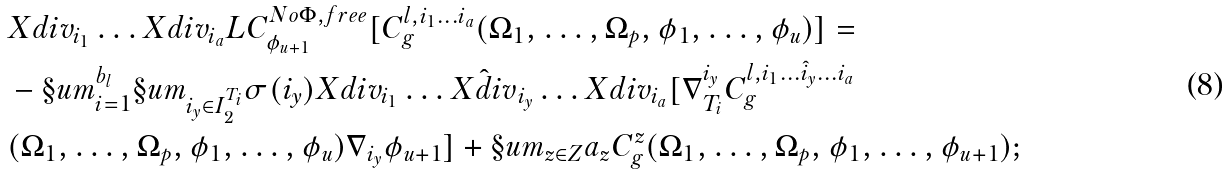Convert formula to latex. <formula><loc_0><loc_0><loc_500><loc_500>& X d i v _ { i _ { 1 } } \dots X d i v _ { i _ { a } } L C ^ { N o \Phi , f r e e } _ { \phi _ { u + 1 } } [ C ^ { l , i _ { 1 } \dots i _ { a } } _ { g } ( \Omega _ { 1 } , \dots , \Omega _ { p } , \phi _ { 1 } , \dots , \phi _ { u } ) ] = \\ & - \S u m _ { i = 1 } ^ { b _ { l } } \S u m _ { i _ { y } \in I ^ { T _ { i } } _ { 2 } } \sigma ( i _ { y } ) X d i v _ { i _ { 1 } } \dots \hat { X d i v } _ { i _ { y } } \dots X d i v _ { i _ { a } } [ \nabla ^ { i _ { y } } _ { T _ { i } } C ^ { l , i _ { 1 } \dots \hat { i } _ { y } \dots i _ { a } } _ { g } \\ & ( \Omega _ { 1 } , \dots , \Omega _ { p } , \phi _ { 1 } , \dots , \phi _ { u } ) \nabla _ { i _ { y } } \phi _ { u + 1 } ] + \S u m _ { z \in Z } a _ { z } C ^ { z } _ { g } ( \Omega _ { 1 } , \dots , \Omega _ { p } , \phi _ { 1 } , \dots , \phi _ { u + 1 } ) ;</formula> 